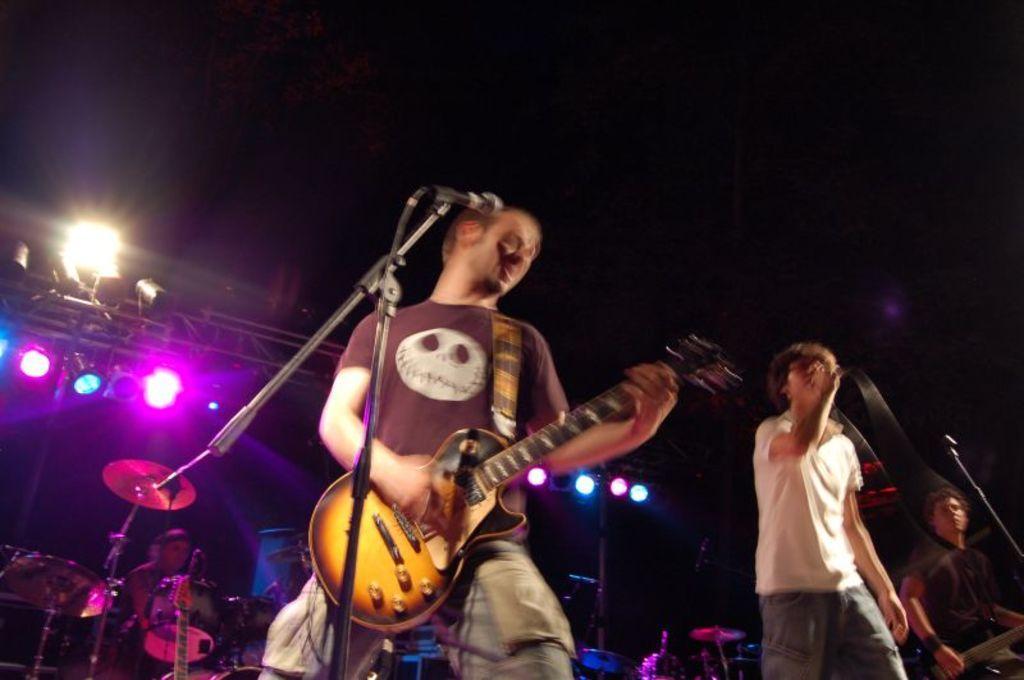Could you give a brief overview of what you see in this image? In this picture there are three boys on the stage those who are singing, and there are having mic and guitar with them, there is a man who is sitting at the left side of the image he is playing the drums and there are spotlights above the area of the image, it seems to be music event. 